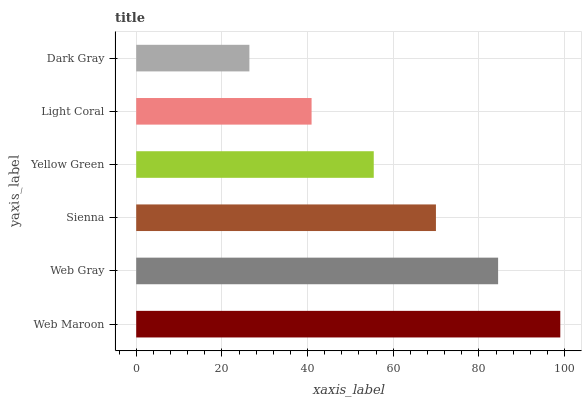Is Dark Gray the minimum?
Answer yes or no. Yes. Is Web Maroon the maximum?
Answer yes or no. Yes. Is Web Gray the minimum?
Answer yes or no. No. Is Web Gray the maximum?
Answer yes or no. No. Is Web Maroon greater than Web Gray?
Answer yes or no. Yes. Is Web Gray less than Web Maroon?
Answer yes or no. Yes. Is Web Gray greater than Web Maroon?
Answer yes or no. No. Is Web Maroon less than Web Gray?
Answer yes or no. No. Is Sienna the high median?
Answer yes or no. Yes. Is Yellow Green the low median?
Answer yes or no. Yes. Is Light Coral the high median?
Answer yes or no. No. Is Dark Gray the low median?
Answer yes or no. No. 